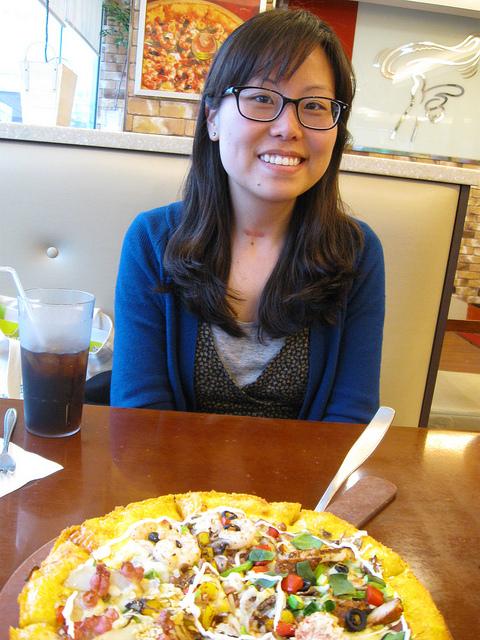Is this person wearing glasses?
Be succinct. Yes. Is the woman smiling?
Answer briefly. Yes. Is this a dress?
Quick response, please. No. What beverage is in the clear cup?
Concise answer only. Soda. 